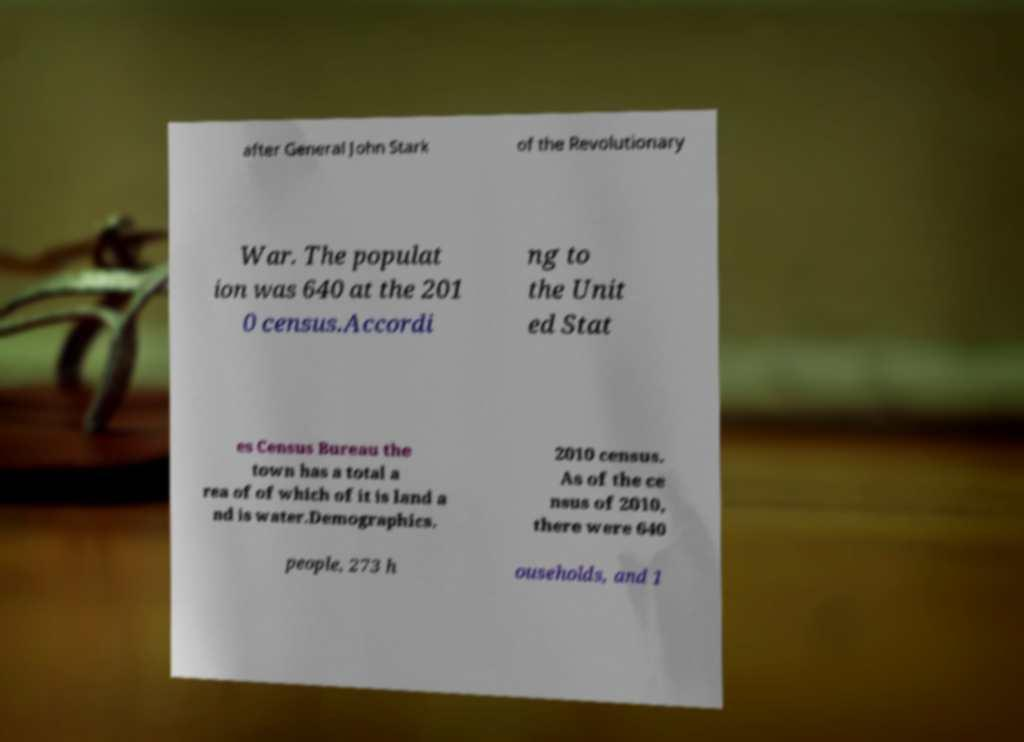I need the written content from this picture converted into text. Can you do that? after General John Stark of the Revolutionary War. The populat ion was 640 at the 201 0 census.Accordi ng to the Unit ed Stat es Census Bureau the town has a total a rea of of which of it is land a nd is water.Demographics. 2010 census. As of the ce nsus of 2010, there were 640 people, 273 h ouseholds, and 1 